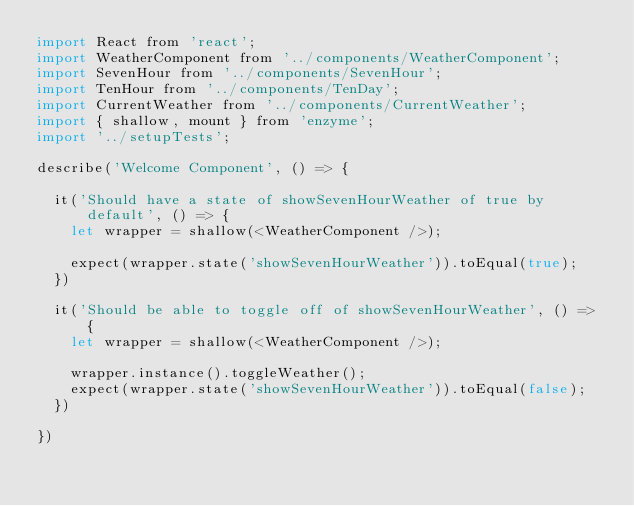<code> <loc_0><loc_0><loc_500><loc_500><_JavaScript_>import React from 'react';
import WeatherComponent from '../components/WeatherComponent';
import SevenHour from '../components/SevenHour';
import TenHour from '../components/TenDay';
import CurrentWeather from '../components/CurrentWeather';
import { shallow, mount } from 'enzyme';
import '../setupTests';

describe('Welcome Component', () => {
  
  it('Should have a state of showSevenHourWeather of true by default', () => {
    let wrapper = shallow(<WeatherComponent />); 

    expect(wrapper.state('showSevenHourWeather')).toEqual(true);
  })

  it('Should be able to toggle off of showSevenHourWeather', () => {
    let wrapper = shallow(<WeatherComponent />);

    wrapper.instance().toggleWeather();
    expect(wrapper.state('showSevenHourWeather')).toEqual(false);  
  })

})</code> 